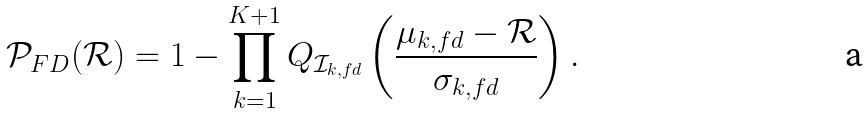Convert formula to latex. <formula><loc_0><loc_0><loc_500><loc_500>\mathcal { P } _ { F D } ( \mathcal { R } ) = 1 - \prod _ { k = 1 } ^ { K + 1 } Q _ { \mathcal { I } _ { k , f d } } \left ( \frac { \mu _ { k , f d } - \mathcal { R } } { \sigma _ { k , f d } } \right ) .</formula> 